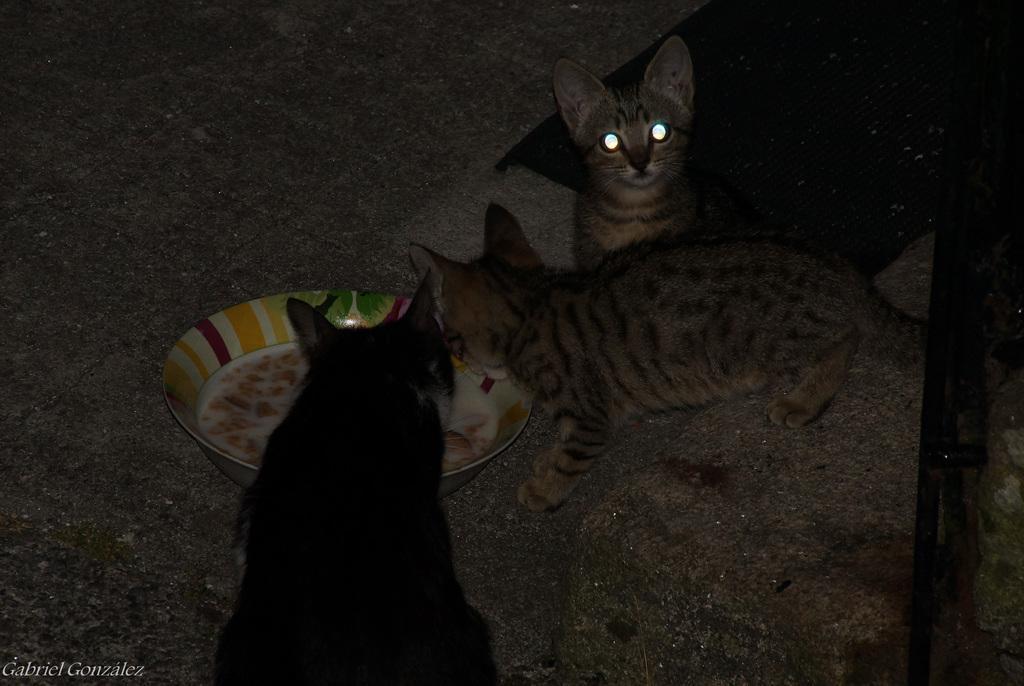How would you summarize this image in a sentence or two? In this image there are two cats eating the food which is in the plate. Beside the cats there is another cat. Behind the cat there is a mat on the floor. On the right side of the image there is a metal rod. There is some text at the bottom of the image. 